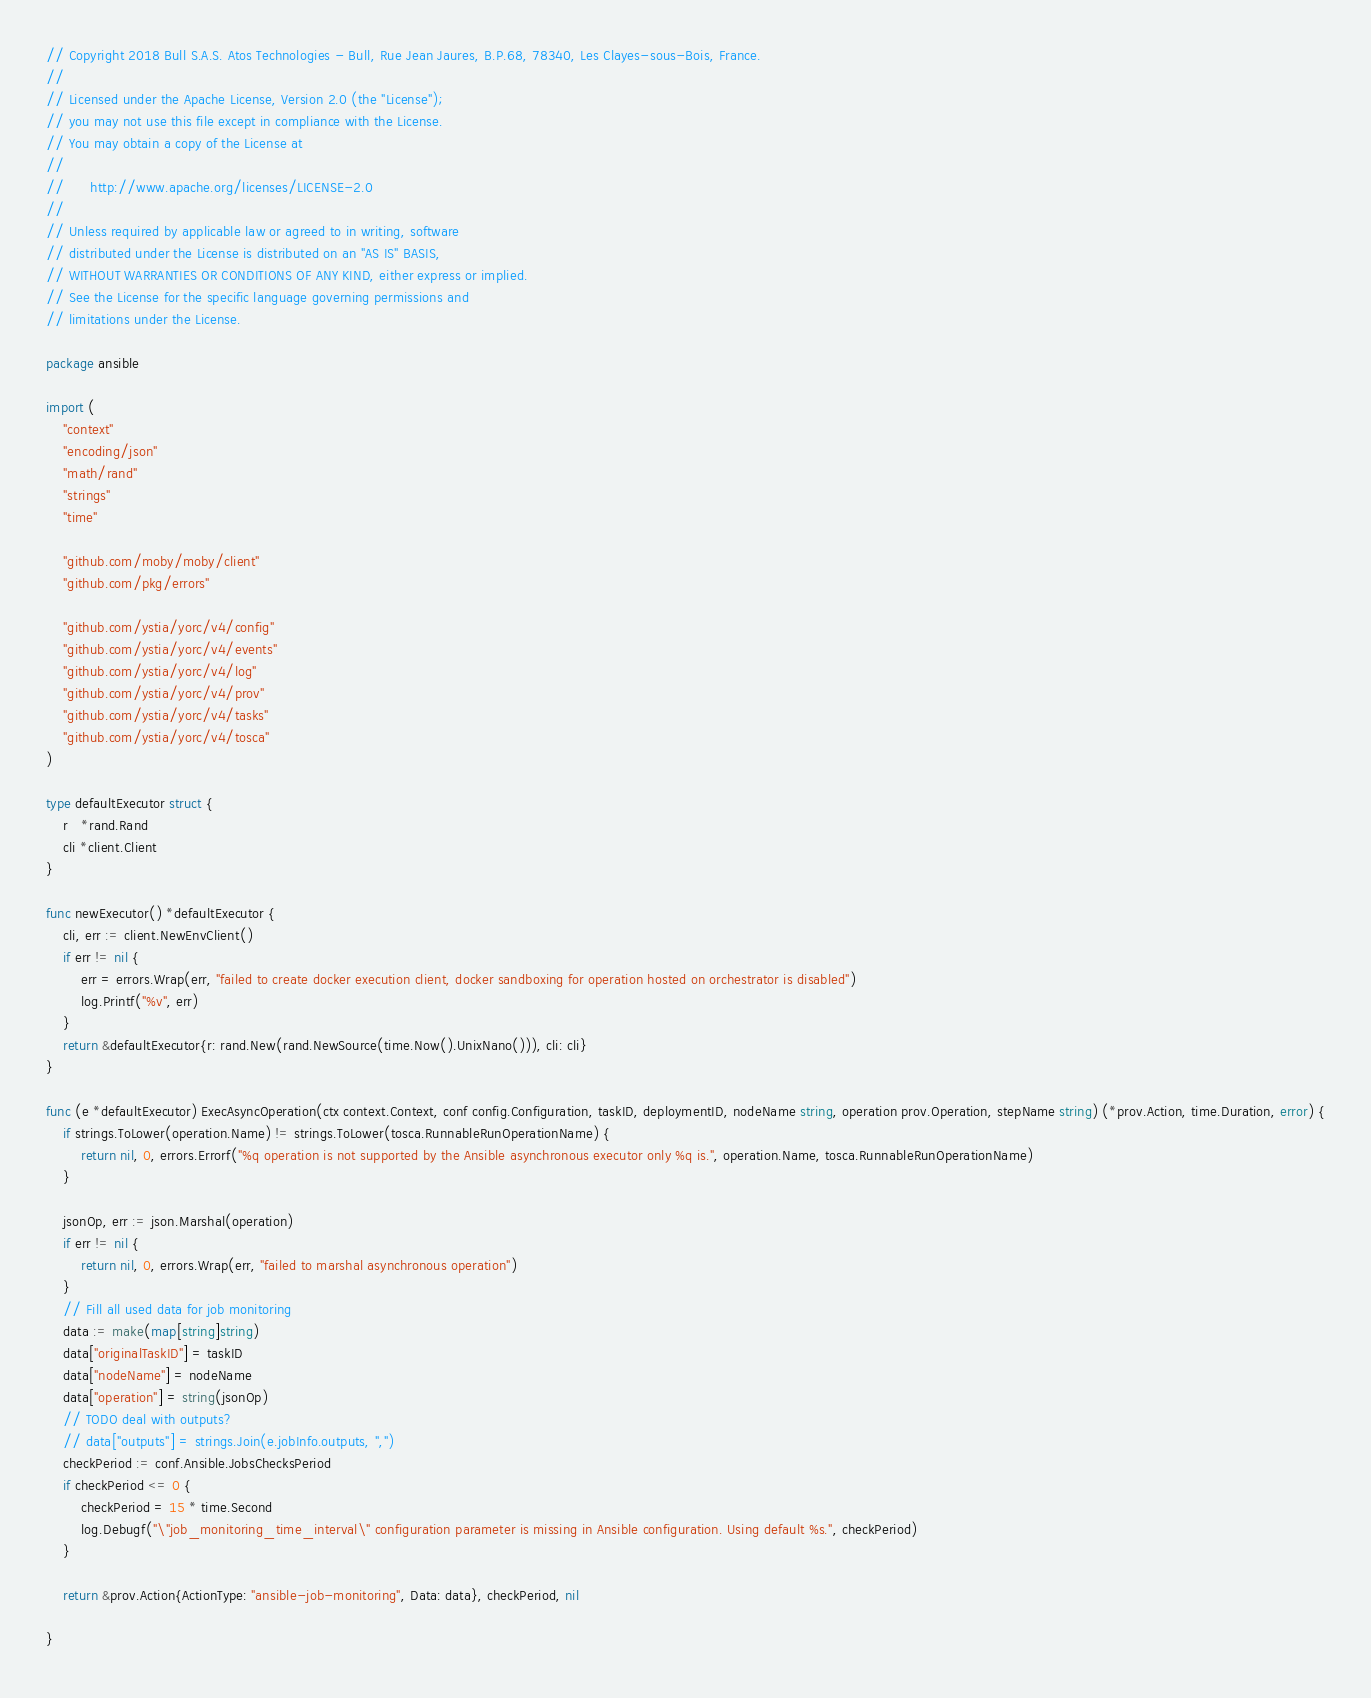Convert code to text. <code><loc_0><loc_0><loc_500><loc_500><_Go_>// Copyright 2018 Bull S.A.S. Atos Technologies - Bull, Rue Jean Jaures, B.P.68, 78340, Les Clayes-sous-Bois, France.
//
// Licensed under the Apache License, Version 2.0 (the "License");
// you may not use this file except in compliance with the License.
// You may obtain a copy of the License at
//
//      http://www.apache.org/licenses/LICENSE-2.0
//
// Unless required by applicable law or agreed to in writing, software
// distributed under the License is distributed on an "AS IS" BASIS,
// WITHOUT WARRANTIES OR CONDITIONS OF ANY KIND, either express or implied.
// See the License for the specific language governing permissions and
// limitations under the License.

package ansible

import (
	"context"
	"encoding/json"
	"math/rand"
	"strings"
	"time"

	"github.com/moby/moby/client"
	"github.com/pkg/errors"

	"github.com/ystia/yorc/v4/config"
	"github.com/ystia/yorc/v4/events"
	"github.com/ystia/yorc/v4/log"
	"github.com/ystia/yorc/v4/prov"
	"github.com/ystia/yorc/v4/tasks"
	"github.com/ystia/yorc/v4/tosca"
)

type defaultExecutor struct {
	r   *rand.Rand
	cli *client.Client
}

func newExecutor() *defaultExecutor {
	cli, err := client.NewEnvClient()
	if err != nil {
		err = errors.Wrap(err, "failed to create docker execution client, docker sandboxing for operation hosted on orchestrator is disabled")
		log.Printf("%v", err)
	}
	return &defaultExecutor{r: rand.New(rand.NewSource(time.Now().UnixNano())), cli: cli}
}

func (e *defaultExecutor) ExecAsyncOperation(ctx context.Context, conf config.Configuration, taskID, deploymentID, nodeName string, operation prov.Operation, stepName string) (*prov.Action, time.Duration, error) {
	if strings.ToLower(operation.Name) != strings.ToLower(tosca.RunnableRunOperationName) {
		return nil, 0, errors.Errorf("%q operation is not supported by the Ansible asynchronous executor only %q is.", operation.Name, tosca.RunnableRunOperationName)
	}

	jsonOp, err := json.Marshal(operation)
	if err != nil {
		return nil, 0, errors.Wrap(err, "failed to marshal asynchronous operation")
	}
	// Fill all used data for job monitoring
	data := make(map[string]string)
	data["originalTaskID"] = taskID
	data["nodeName"] = nodeName
	data["operation"] = string(jsonOp)
	// TODO deal with outputs?
	// data["outputs"] = strings.Join(e.jobInfo.outputs, ",")
	checkPeriod := conf.Ansible.JobsChecksPeriod
	if checkPeriod <= 0 {
		checkPeriod = 15 * time.Second
		log.Debugf("\"job_monitoring_time_interval\" configuration parameter is missing in Ansible configuration. Using default %s.", checkPeriod)
	}

	return &prov.Action{ActionType: "ansible-job-monitoring", Data: data}, checkPeriod, nil

}
</code> 